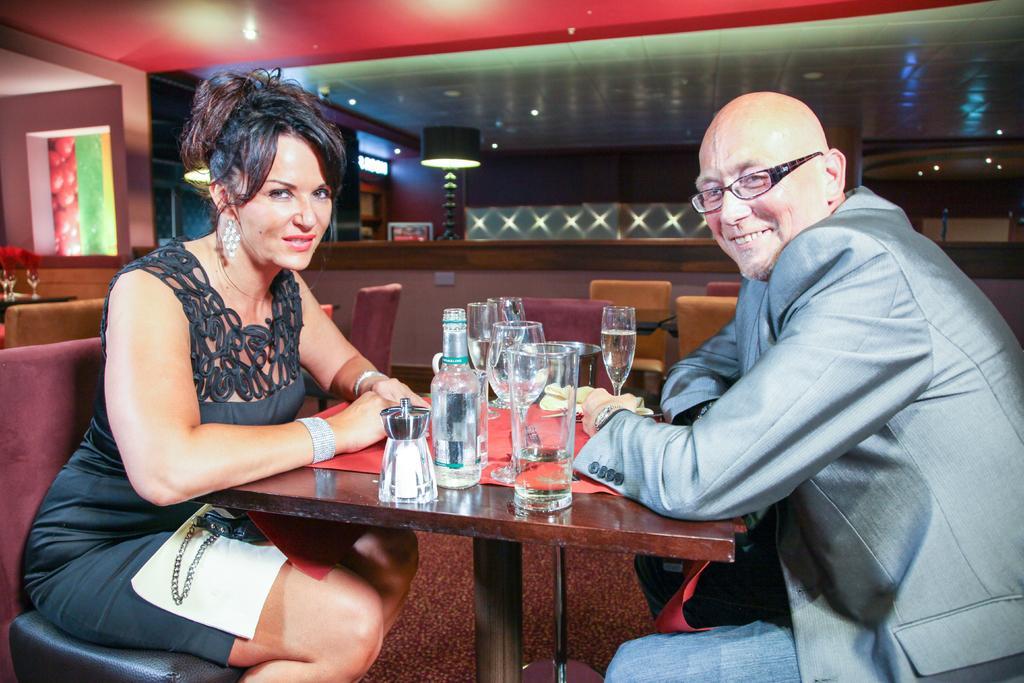Please provide a concise description of this image. This the picture taken in a restaurant, there are two persons sitting on chairs. The woman in black dress in her lap there is a towel and wallet. In front of the people there is a table on the table there are glasses, bottle, mat and food items. behind the people there is a glass window, lamp and a wall. 